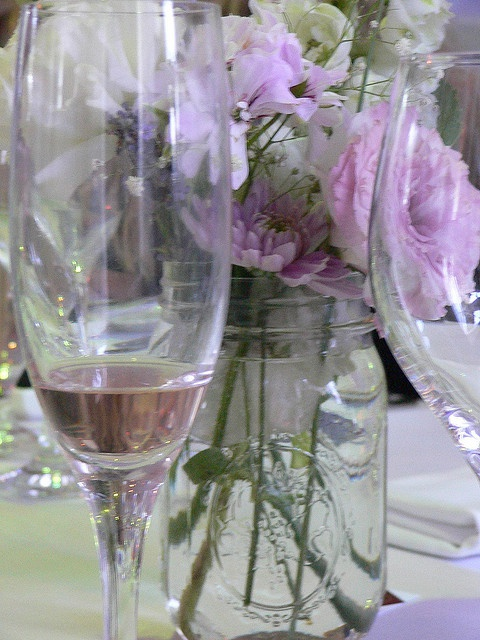Describe the objects in this image and their specific colors. I can see wine glass in gray, darkgray, and lightgray tones, vase in gray, darkgray, darkgreen, and black tones, and wine glass in gray, darkgray, violet, and lavender tones in this image. 